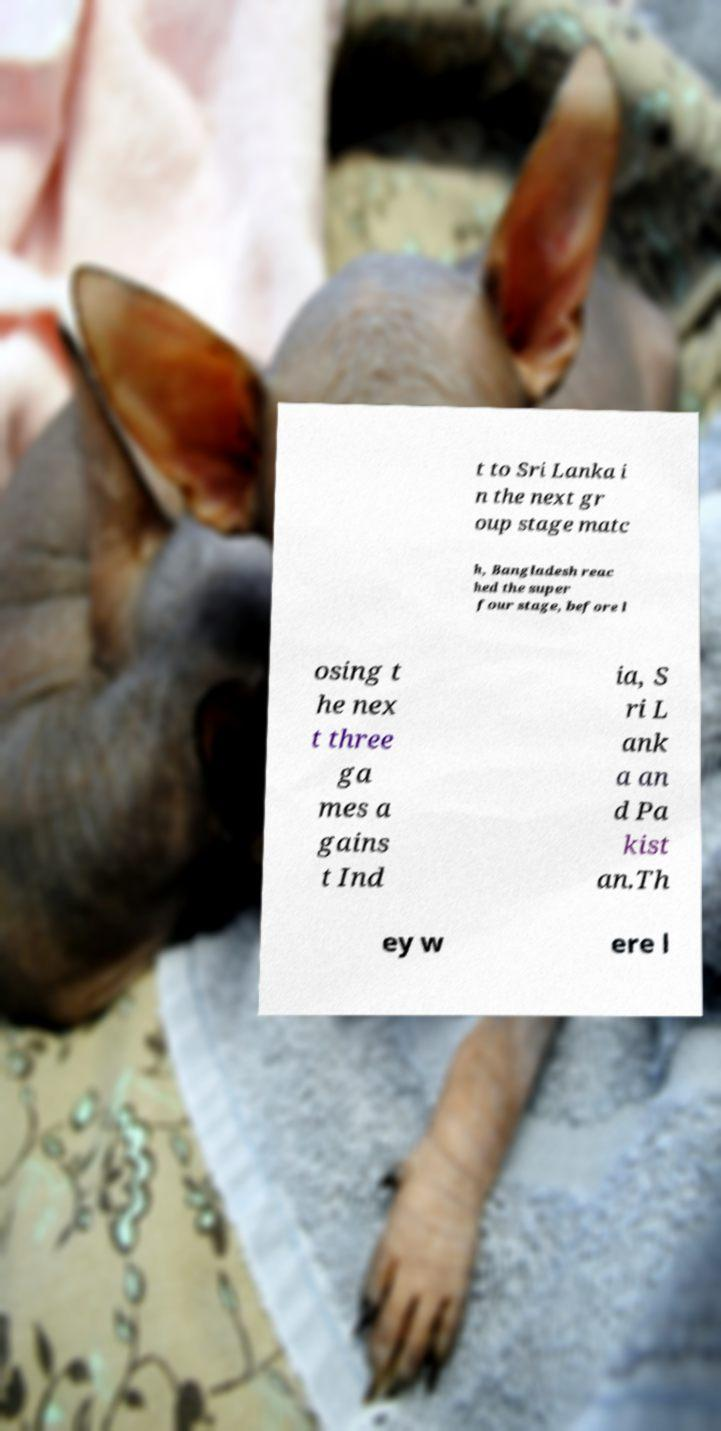Could you assist in decoding the text presented in this image and type it out clearly? t to Sri Lanka i n the next gr oup stage matc h, Bangladesh reac hed the super four stage, before l osing t he nex t three ga mes a gains t Ind ia, S ri L ank a an d Pa kist an.Th ey w ere l 